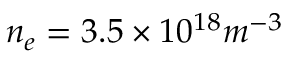<formula> <loc_0><loc_0><loc_500><loc_500>n _ { e } = 3 . 5 \times 1 0 ^ { 1 8 } m ^ { - 3 }</formula> 